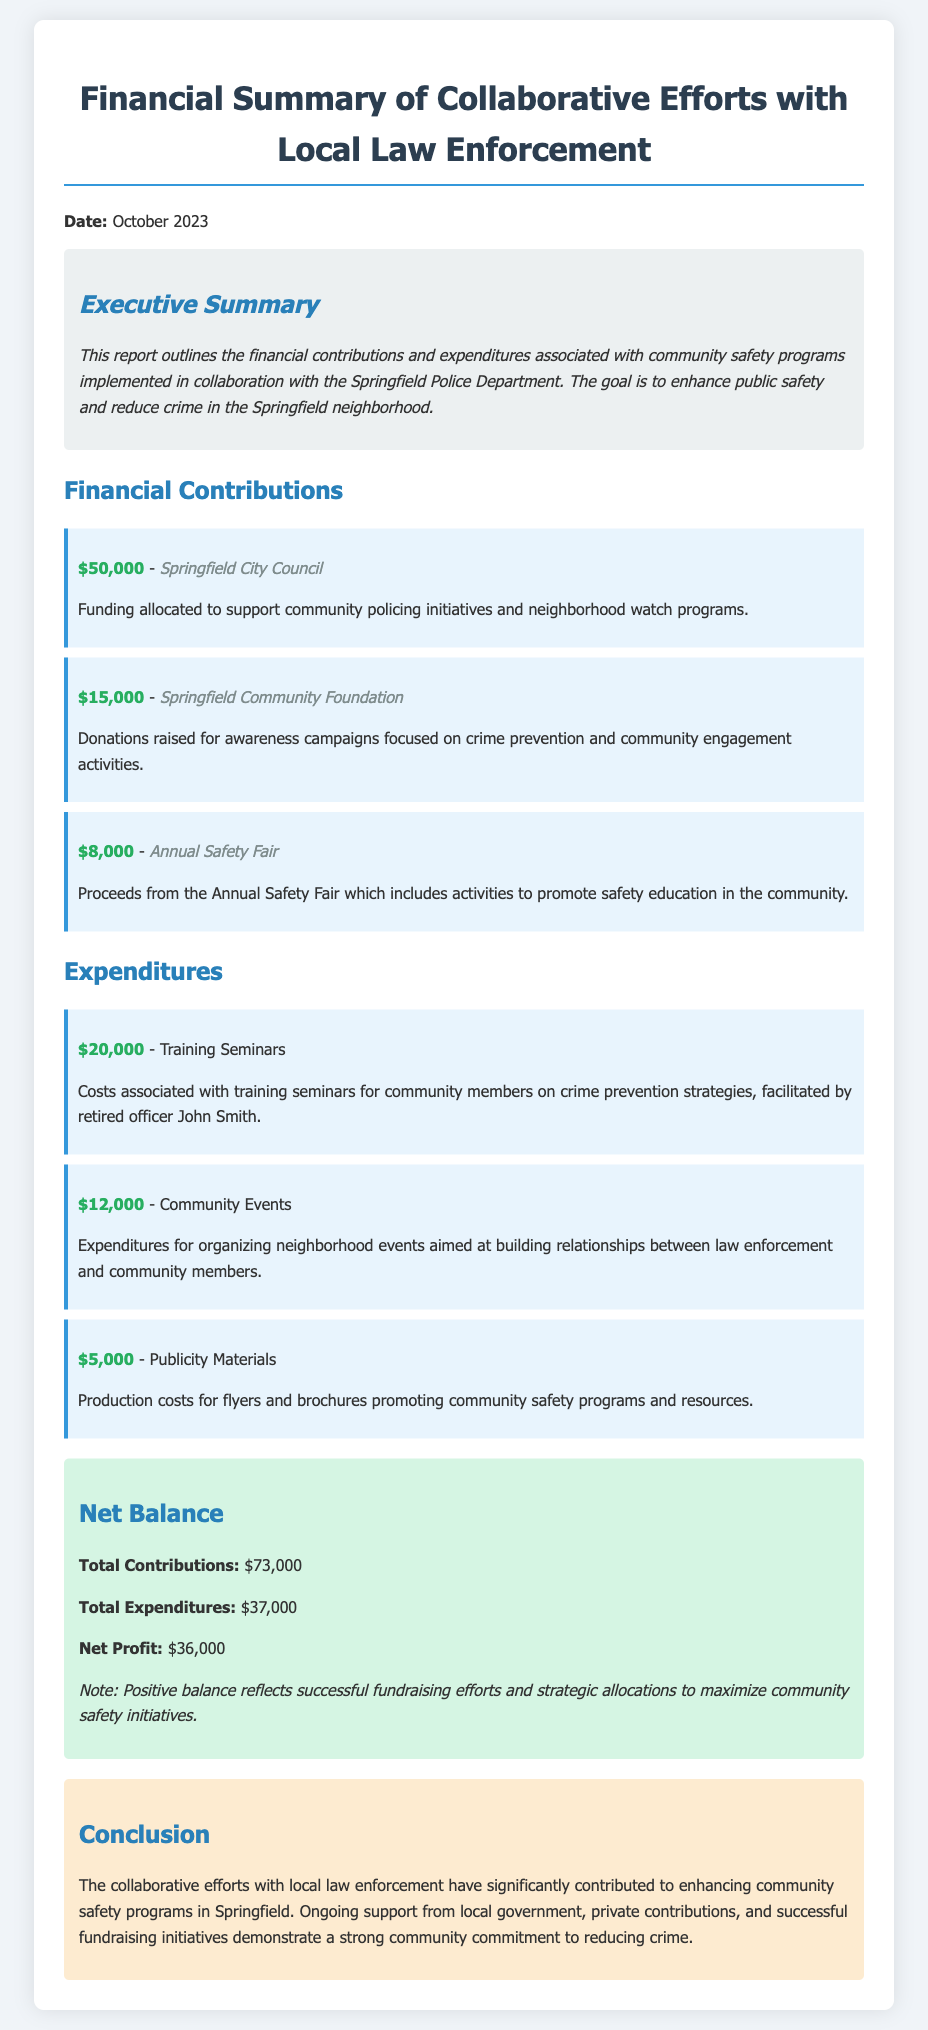What is the total funding from the Springfield City Council? The total funding from the Springfield City Council, as listed in the document, is $50,000.
Answer: $50,000 What were the expenditures for Training Seminars? The expenditures for Training Seminars are shown to be $20,000 in the financial summary.
Answer: $20,000 What was the source of $15,000 in contributions? The source of $15,000 in contributions is the Springfield Community Foundation.
Answer: Springfield Community Foundation What is the total net profit reported? The net profit reported is the difference between total contributions and expenditures, which is $36,000.
Answer: $36,000 How much was allocated for Community Events? The amount allocated for Community Events is listed as $12,000 in the expenditures section.
Answer: $12,000 What is the purpose of the Annual Safety Fair? The purpose of the Annual Safety Fair is to raise funds for safety education activities in the community, totaling $8,000.
Answer: Proceeds from the Annual Safety Fair What is the total amount of financial contributions? The total amount of financial contributions is calculated as $73,000 in the financial summary.
Answer: $73,000 Who facilitated the Training Seminars? The Training Seminars were facilitated by retired officer John Smith, as mentioned in the expenditures section.
Answer: John Smith What color represents the net balance section in the document? The net balance section is represented in a light green background color according to the styling of the document.
Answer: Light green 